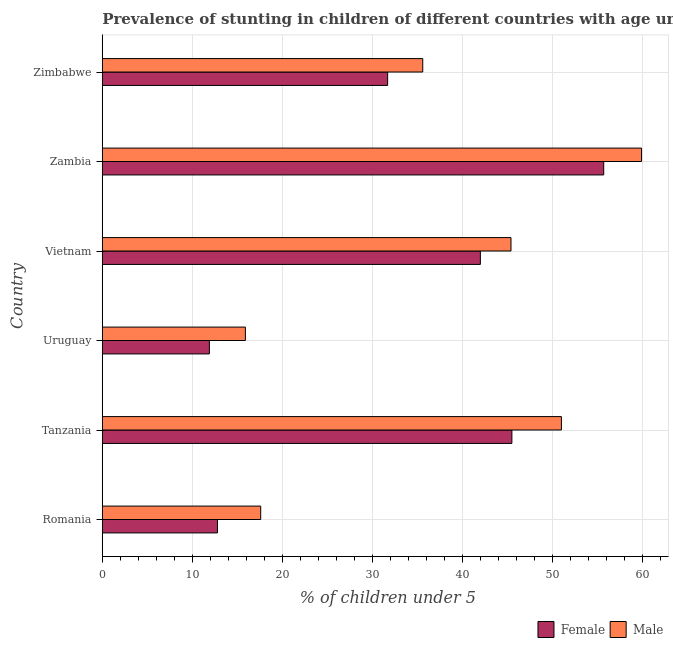Are the number of bars per tick equal to the number of legend labels?
Offer a very short reply. Yes. How many bars are there on the 2nd tick from the top?
Make the answer very short. 2. What is the label of the 6th group of bars from the top?
Your answer should be very brief. Romania. What is the percentage of stunted male children in Zimbabwe?
Make the answer very short. 35.6. Across all countries, what is the maximum percentage of stunted female children?
Your answer should be very brief. 55.7. Across all countries, what is the minimum percentage of stunted female children?
Provide a short and direct response. 11.9. In which country was the percentage of stunted female children maximum?
Your answer should be very brief. Zambia. In which country was the percentage of stunted male children minimum?
Ensure brevity in your answer.  Uruguay. What is the total percentage of stunted male children in the graph?
Your response must be concise. 225.4. What is the difference between the percentage of stunted male children in Tanzania and that in Vietnam?
Your response must be concise. 5.6. What is the difference between the percentage of stunted male children in Zambia and the percentage of stunted female children in Tanzania?
Provide a short and direct response. 14.4. What is the average percentage of stunted male children per country?
Give a very brief answer. 37.57. What is the difference between the percentage of stunted male children and percentage of stunted female children in Uruguay?
Give a very brief answer. 4. What is the ratio of the percentage of stunted female children in Zambia to that in Zimbabwe?
Offer a terse response. 1.76. Is the difference between the percentage of stunted male children in Tanzania and Vietnam greater than the difference between the percentage of stunted female children in Tanzania and Vietnam?
Your answer should be very brief. Yes. What is the difference between the highest and the lowest percentage of stunted female children?
Ensure brevity in your answer.  43.8. In how many countries, is the percentage of stunted male children greater than the average percentage of stunted male children taken over all countries?
Your answer should be very brief. 3. What does the 1st bar from the bottom in Romania represents?
Ensure brevity in your answer.  Female. How many bars are there?
Keep it short and to the point. 12. What is the difference between two consecutive major ticks on the X-axis?
Keep it short and to the point. 10. Are the values on the major ticks of X-axis written in scientific E-notation?
Your answer should be compact. No. Does the graph contain grids?
Offer a very short reply. Yes. How many legend labels are there?
Make the answer very short. 2. How are the legend labels stacked?
Make the answer very short. Horizontal. What is the title of the graph?
Provide a succinct answer. Prevalence of stunting in children of different countries with age under 5 years. Does "Fertility rate" appear as one of the legend labels in the graph?
Your response must be concise. No. What is the label or title of the X-axis?
Your response must be concise.  % of children under 5. What is the  % of children under 5 in Female in Romania?
Your answer should be compact. 12.8. What is the  % of children under 5 of Male in Romania?
Make the answer very short. 17.6. What is the  % of children under 5 of Female in Tanzania?
Give a very brief answer. 45.5. What is the  % of children under 5 of Male in Tanzania?
Ensure brevity in your answer.  51. What is the  % of children under 5 in Female in Uruguay?
Make the answer very short. 11.9. What is the  % of children under 5 of Male in Uruguay?
Ensure brevity in your answer.  15.9. What is the  % of children under 5 of Male in Vietnam?
Ensure brevity in your answer.  45.4. What is the  % of children under 5 in Female in Zambia?
Provide a succinct answer. 55.7. What is the  % of children under 5 of Male in Zambia?
Make the answer very short. 59.9. What is the  % of children under 5 in Female in Zimbabwe?
Provide a short and direct response. 31.7. What is the  % of children under 5 in Male in Zimbabwe?
Offer a terse response. 35.6. Across all countries, what is the maximum  % of children under 5 in Female?
Keep it short and to the point. 55.7. Across all countries, what is the maximum  % of children under 5 in Male?
Make the answer very short. 59.9. Across all countries, what is the minimum  % of children under 5 in Female?
Make the answer very short. 11.9. Across all countries, what is the minimum  % of children under 5 of Male?
Your answer should be compact. 15.9. What is the total  % of children under 5 in Female in the graph?
Provide a short and direct response. 199.6. What is the total  % of children under 5 in Male in the graph?
Keep it short and to the point. 225.4. What is the difference between the  % of children under 5 in Female in Romania and that in Tanzania?
Make the answer very short. -32.7. What is the difference between the  % of children under 5 of Male in Romania and that in Tanzania?
Ensure brevity in your answer.  -33.4. What is the difference between the  % of children under 5 in Female in Romania and that in Vietnam?
Your response must be concise. -29.2. What is the difference between the  % of children under 5 in Male in Romania and that in Vietnam?
Provide a succinct answer. -27.8. What is the difference between the  % of children under 5 in Female in Romania and that in Zambia?
Your answer should be compact. -42.9. What is the difference between the  % of children under 5 in Male in Romania and that in Zambia?
Offer a very short reply. -42.3. What is the difference between the  % of children under 5 of Female in Romania and that in Zimbabwe?
Your answer should be compact. -18.9. What is the difference between the  % of children under 5 of Male in Romania and that in Zimbabwe?
Keep it short and to the point. -18. What is the difference between the  % of children under 5 of Female in Tanzania and that in Uruguay?
Offer a terse response. 33.6. What is the difference between the  % of children under 5 of Male in Tanzania and that in Uruguay?
Provide a succinct answer. 35.1. What is the difference between the  % of children under 5 in Female in Tanzania and that in Vietnam?
Provide a short and direct response. 3.5. What is the difference between the  % of children under 5 in Female in Tanzania and that in Zambia?
Provide a short and direct response. -10.2. What is the difference between the  % of children under 5 in Male in Tanzania and that in Zambia?
Provide a succinct answer. -8.9. What is the difference between the  % of children under 5 in Female in Uruguay and that in Vietnam?
Your response must be concise. -30.1. What is the difference between the  % of children under 5 in Male in Uruguay and that in Vietnam?
Your response must be concise. -29.5. What is the difference between the  % of children under 5 of Female in Uruguay and that in Zambia?
Give a very brief answer. -43.8. What is the difference between the  % of children under 5 in Male in Uruguay and that in Zambia?
Your answer should be very brief. -44. What is the difference between the  % of children under 5 of Female in Uruguay and that in Zimbabwe?
Give a very brief answer. -19.8. What is the difference between the  % of children under 5 of Male in Uruguay and that in Zimbabwe?
Make the answer very short. -19.7. What is the difference between the  % of children under 5 of Female in Vietnam and that in Zambia?
Offer a terse response. -13.7. What is the difference between the  % of children under 5 in Female in Zambia and that in Zimbabwe?
Your answer should be compact. 24. What is the difference between the  % of children under 5 in Male in Zambia and that in Zimbabwe?
Provide a succinct answer. 24.3. What is the difference between the  % of children under 5 in Female in Romania and the  % of children under 5 in Male in Tanzania?
Give a very brief answer. -38.2. What is the difference between the  % of children under 5 of Female in Romania and the  % of children under 5 of Male in Vietnam?
Provide a short and direct response. -32.6. What is the difference between the  % of children under 5 of Female in Romania and the  % of children under 5 of Male in Zambia?
Your response must be concise. -47.1. What is the difference between the  % of children under 5 in Female in Romania and the  % of children under 5 in Male in Zimbabwe?
Offer a terse response. -22.8. What is the difference between the  % of children under 5 of Female in Tanzania and the  % of children under 5 of Male in Uruguay?
Provide a succinct answer. 29.6. What is the difference between the  % of children under 5 in Female in Tanzania and the  % of children under 5 in Male in Zambia?
Keep it short and to the point. -14.4. What is the difference between the  % of children under 5 in Female in Tanzania and the  % of children under 5 in Male in Zimbabwe?
Your answer should be very brief. 9.9. What is the difference between the  % of children under 5 in Female in Uruguay and the  % of children under 5 in Male in Vietnam?
Offer a very short reply. -33.5. What is the difference between the  % of children under 5 in Female in Uruguay and the  % of children under 5 in Male in Zambia?
Your response must be concise. -48. What is the difference between the  % of children under 5 in Female in Uruguay and the  % of children under 5 in Male in Zimbabwe?
Ensure brevity in your answer.  -23.7. What is the difference between the  % of children under 5 in Female in Vietnam and the  % of children under 5 in Male in Zambia?
Your answer should be very brief. -17.9. What is the difference between the  % of children under 5 of Female in Zambia and the  % of children under 5 of Male in Zimbabwe?
Your response must be concise. 20.1. What is the average  % of children under 5 in Female per country?
Give a very brief answer. 33.27. What is the average  % of children under 5 of Male per country?
Provide a short and direct response. 37.57. What is the difference between the  % of children under 5 of Female and  % of children under 5 of Male in Romania?
Give a very brief answer. -4.8. What is the difference between the  % of children under 5 of Female and  % of children under 5 of Male in Tanzania?
Provide a succinct answer. -5.5. What is the difference between the  % of children under 5 in Female and  % of children under 5 in Male in Uruguay?
Your answer should be very brief. -4. What is the difference between the  % of children under 5 in Female and  % of children under 5 in Male in Vietnam?
Ensure brevity in your answer.  -3.4. What is the difference between the  % of children under 5 of Female and  % of children under 5 of Male in Zambia?
Offer a very short reply. -4.2. What is the difference between the  % of children under 5 in Female and  % of children under 5 in Male in Zimbabwe?
Provide a short and direct response. -3.9. What is the ratio of the  % of children under 5 of Female in Romania to that in Tanzania?
Your response must be concise. 0.28. What is the ratio of the  % of children under 5 of Male in Romania to that in Tanzania?
Provide a short and direct response. 0.35. What is the ratio of the  % of children under 5 of Female in Romania to that in Uruguay?
Provide a short and direct response. 1.08. What is the ratio of the  % of children under 5 of Male in Romania to that in Uruguay?
Your answer should be very brief. 1.11. What is the ratio of the  % of children under 5 in Female in Romania to that in Vietnam?
Your answer should be compact. 0.3. What is the ratio of the  % of children under 5 of Male in Romania to that in Vietnam?
Ensure brevity in your answer.  0.39. What is the ratio of the  % of children under 5 in Female in Romania to that in Zambia?
Ensure brevity in your answer.  0.23. What is the ratio of the  % of children under 5 in Male in Romania to that in Zambia?
Keep it short and to the point. 0.29. What is the ratio of the  % of children under 5 in Female in Romania to that in Zimbabwe?
Your answer should be compact. 0.4. What is the ratio of the  % of children under 5 in Male in Romania to that in Zimbabwe?
Offer a very short reply. 0.49. What is the ratio of the  % of children under 5 in Female in Tanzania to that in Uruguay?
Offer a terse response. 3.82. What is the ratio of the  % of children under 5 of Male in Tanzania to that in Uruguay?
Provide a succinct answer. 3.21. What is the ratio of the  % of children under 5 in Female in Tanzania to that in Vietnam?
Your response must be concise. 1.08. What is the ratio of the  % of children under 5 of Male in Tanzania to that in Vietnam?
Your answer should be compact. 1.12. What is the ratio of the  % of children under 5 of Female in Tanzania to that in Zambia?
Make the answer very short. 0.82. What is the ratio of the  % of children under 5 in Male in Tanzania to that in Zambia?
Offer a very short reply. 0.85. What is the ratio of the  % of children under 5 in Female in Tanzania to that in Zimbabwe?
Give a very brief answer. 1.44. What is the ratio of the  % of children under 5 of Male in Tanzania to that in Zimbabwe?
Provide a succinct answer. 1.43. What is the ratio of the  % of children under 5 in Female in Uruguay to that in Vietnam?
Give a very brief answer. 0.28. What is the ratio of the  % of children under 5 of Male in Uruguay to that in Vietnam?
Provide a short and direct response. 0.35. What is the ratio of the  % of children under 5 in Female in Uruguay to that in Zambia?
Ensure brevity in your answer.  0.21. What is the ratio of the  % of children under 5 in Male in Uruguay to that in Zambia?
Your answer should be very brief. 0.27. What is the ratio of the  % of children under 5 of Female in Uruguay to that in Zimbabwe?
Keep it short and to the point. 0.38. What is the ratio of the  % of children under 5 of Male in Uruguay to that in Zimbabwe?
Provide a short and direct response. 0.45. What is the ratio of the  % of children under 5 in Female in Vietnam to that in Zambia?
Ensure brevity in your answer.  0.75. What is the ratio of the  % of children under 5 of Male in Vietnam to that in Zambia?
Your response must be concise. 0.76. What is the ratio of the  % of children under 5 in Female in Vietnam to that in Zimbabwe?
Ensure brevity in your answer.  1.32. What is the ratio of the  % of children under 5 in Male in Vietnam to that in Zimbabwe?
Your response must be concise. 1.28. What is the ratio of the  % of children under 5 of Female in Zambia to that in Zimbabwe?
Your response must be concise. 1.76. What is the ratio of the  % of children under 5 of Male in Zambia to that in Zimbabwe?
Your response must be concise. 1.68. What is the difference between the highest and the second highest  % of children under 5 of Female?
Your answer should be compact. 10.2. What is the difference between the highest and the lowest  % of children under 5 in Female?
Make the answer very short. 43.8. What is the difference between the highest and the lowest  % of children under 5 of Male?
Your answer should be compact. 44. 